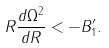Convert formula to latex. <formula><loc_0><loc_0><loc_500><loc_500>R \frac { d \Omega ^ { 2 } } { d R } < - B _ { 1 } ^ { \prime } .</formula> 